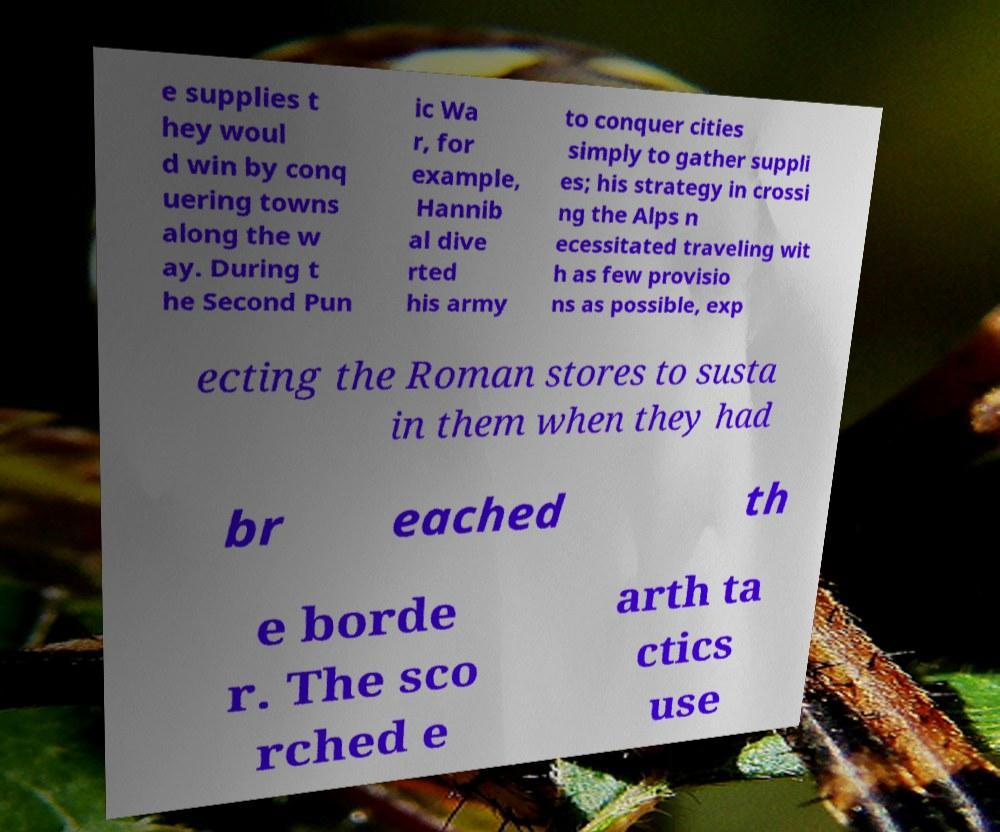I need the written content from this picture converted into text. Can you do that? e supplies t hey woul d win by conq uering towns along the w ay. During t he Second Pun ic Wa r, for example, Hannib al dive rted his army to conquer cities simply to gather suppli es; his strategy in crossi ng the Alps n ecessitated traveling wit h as few provisio ns as possible, exp ecting the Roman stores to susta in them when they had br eached th e borde r. The sco rched e arth ta ctics use 